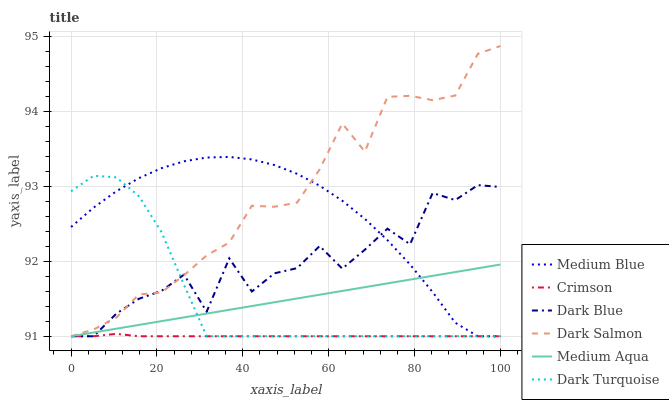Does Crimson have the minimum area under the curve?
Answer yes or no. Yes. Does Dark Salmon have the maximum area under the curve?
Answer yes or no. Yes. Does Medium Blue have the minimum area under the curve?
Answer yes or no. No. Does Medium Blue have the maximum area under the curve?
Answer yes or no. No. Is Medium Aqua the smoothest?
Answer yes or no. Yes. Is Dark Blue the roughest?
Answer yes or no. Yes. Is Medium Blue the smoothest?
Answer yes or no. No. Is Medium Blue the roughest?
Answer yes or no. No. Does Dark Turquoise have the lowest value?
Answer yes or no. Yes. Does Dark Salmon have the highest value?
Answer yes or no. Yes. Does Medium Blue have the highest value?
Answer yes or no. No. Does Dark Blue intersect Dark Turquoise?
Answer yes or no. Yes. Is Dark Blue less than Dark Turquoise?
Answer yes or no. No. Is Dark Blue greater than Dark Turquoise?
Answer yes or no. No. 